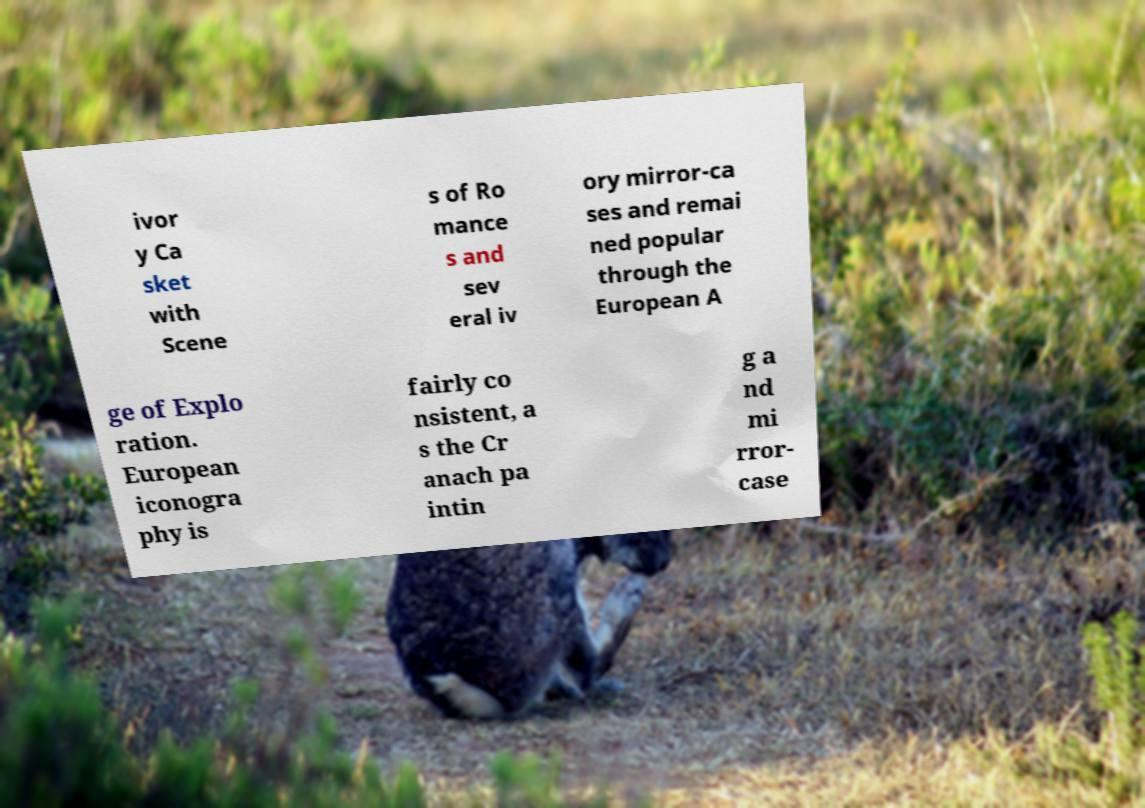Please identify and transcribe the text found in this image. ivor y Ca sket with Scene s of Ro mance s and sev eral iv ory mirror-ca ses and remai ned popular through the European A ge of Explo ration. European iconogra phy is fairly co nsistent, a s the Cr anach pa intin g a nd mi rror- case 